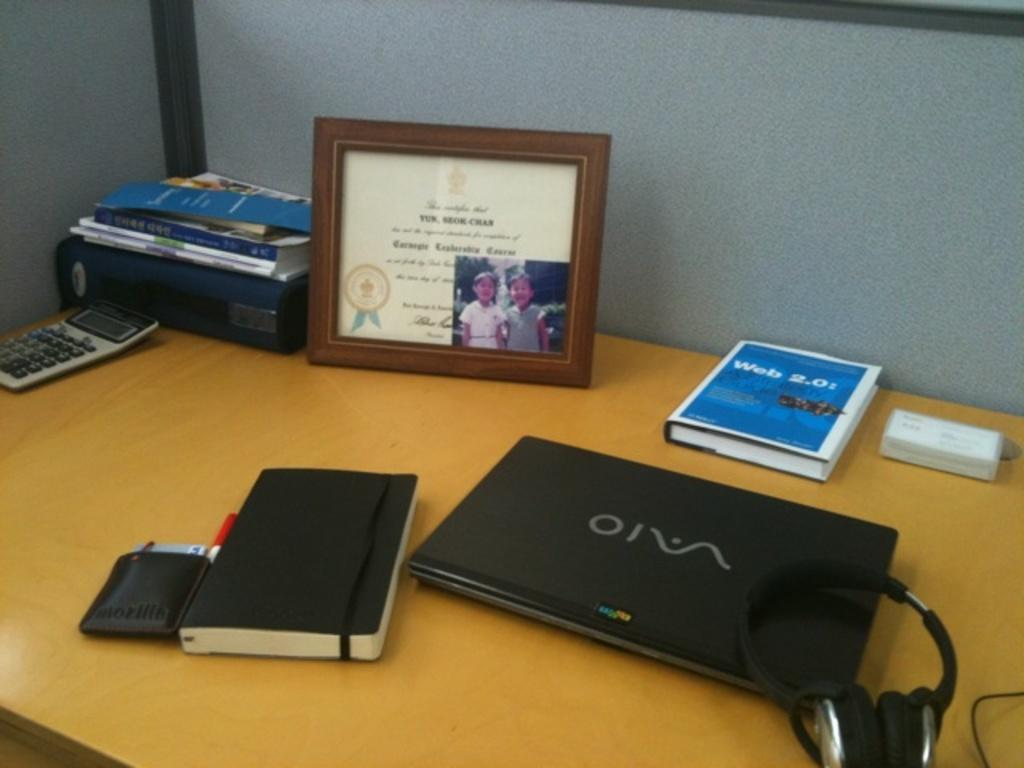<image>
Create a compact narrative representing the image presented. A laptop is displayed on a desk next to the book Web 2.0 